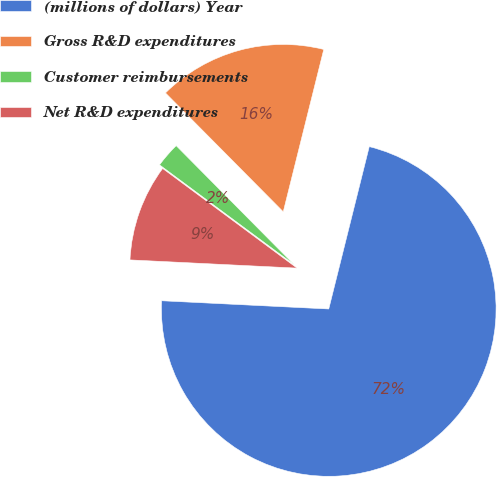Convert chart to OTSL. <chart><loc_0><loc_0><loc_500><loc_500><pie_chart><fcel>(millions of dollars) Year<fcel>Gross R&D expenditures<fcel>Customer reimbursements<fcel>Net R&D expenditures<nl><fcel>71.89%<fcel>16.32%<fcel>2.42%<fcel>9.37%<nl></chart> 